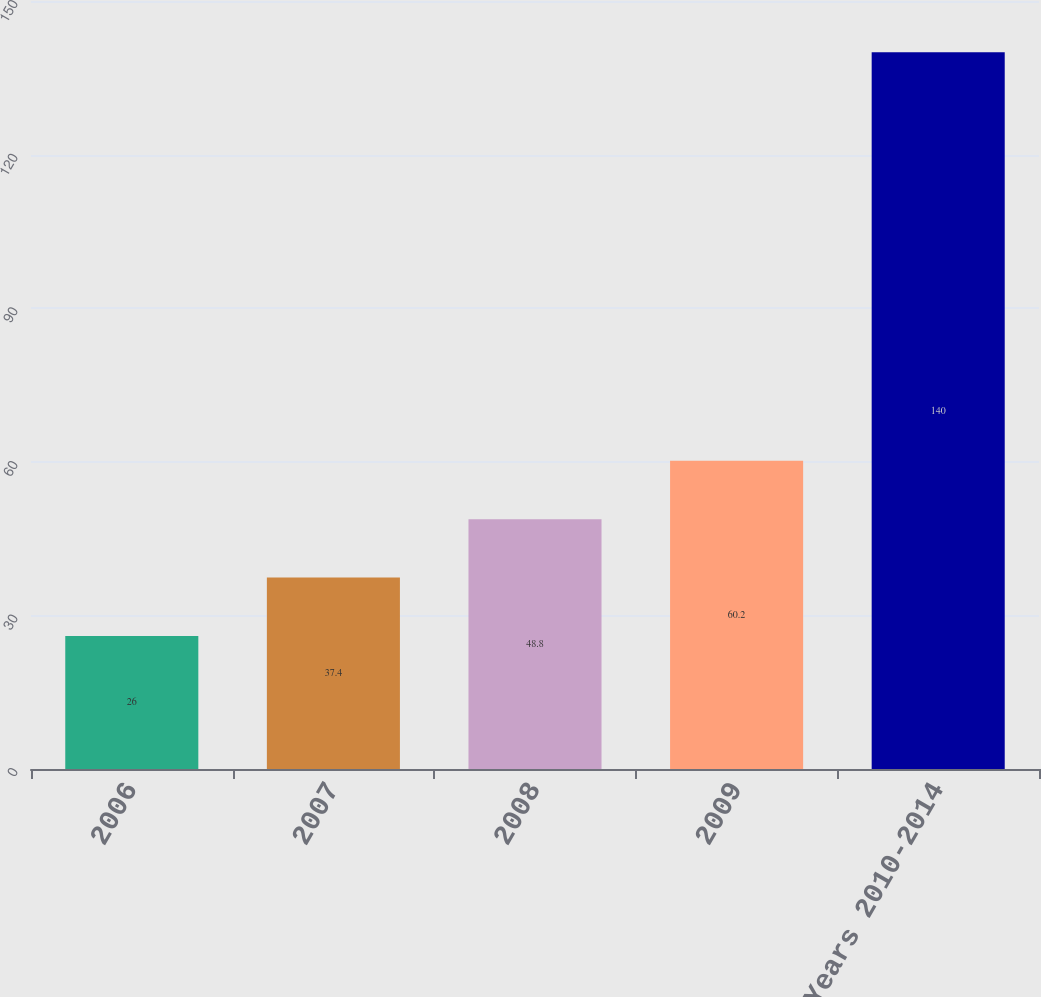Convert chart. <chart><loc_0><loc_0><loc_500><loc_500><bar_chart><fcel>2006<fcel>2007<fcel>2008<fcel>2009<fcel>Years 2010-2014<nl><fcel>26<fcel>37.4<fcel>48.8<fcel>60.2<fcel>140<nl></chart> 